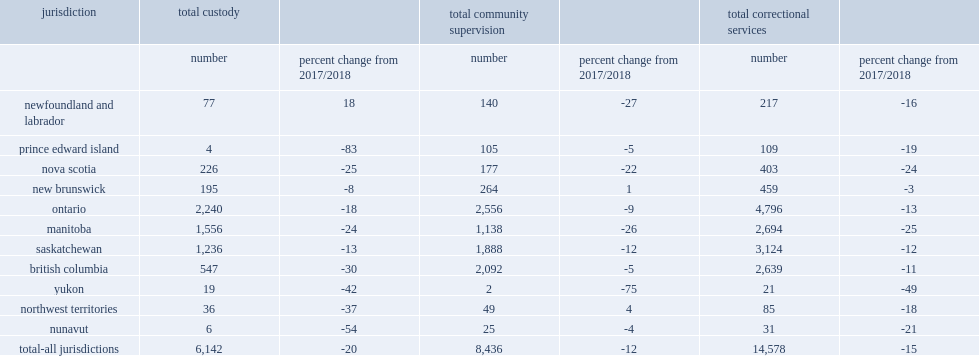What was the total number of youth admissions to correctional services among the 11 reporting jurisdictions? 14578.0. What was the percentage of total number of youth admissions to correctional services among the 11 reporting jurisdictions changed compared to 2017/2018? -15.0. What were the percentages of total number of youth admissions to community supervision and custody changed compared to 2017/2018 respectively? -12.0 -20.0. Among manitoba, nova scotia , prince edward island and newfoundland and labrador, what were their percentages of total number of youth admissions to correctional services changed compared to 2017/2018? -25.0 -24.0 -19.0 -16.0. Among the territories,which had the largest decrease in total admissions to correctional services compared to 2017/2018? Yukon. 